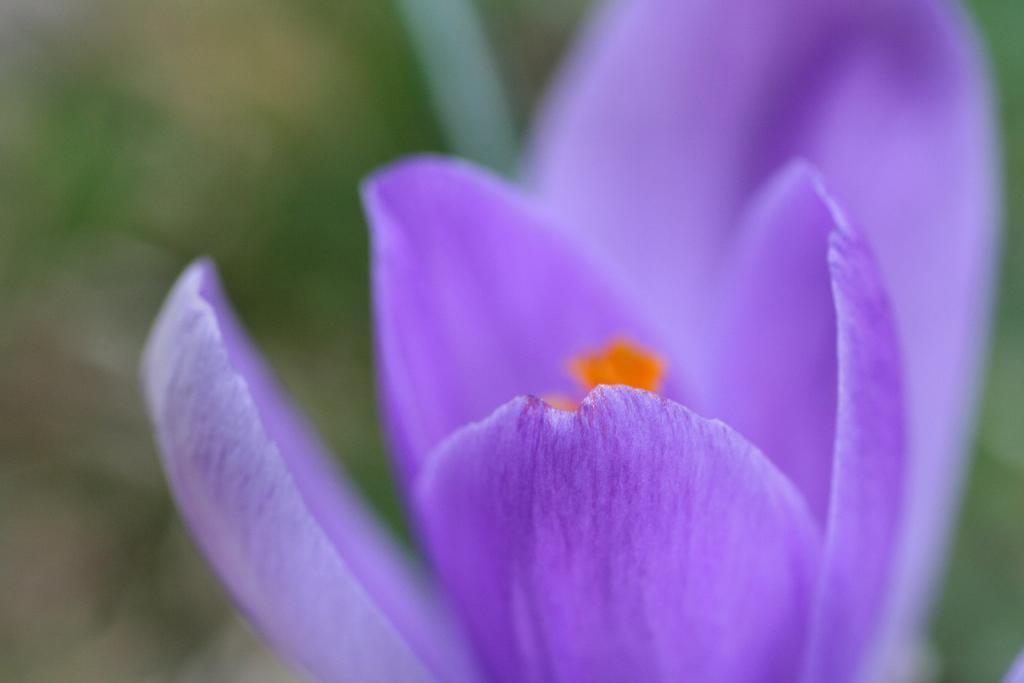Please provide a concise description of this image. In this picture there is a purple color flower in the foreground. At the back the image is blurry and there might be a plant. 